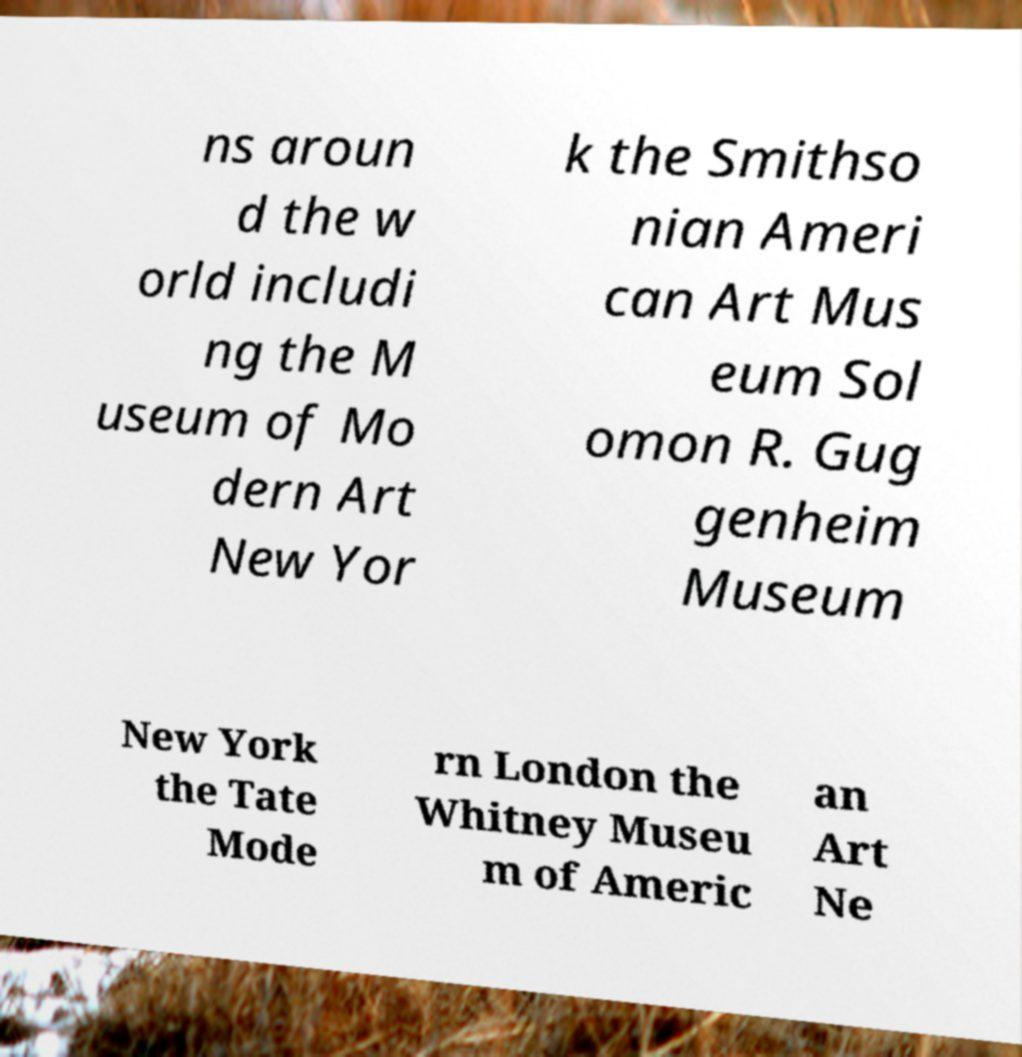Please read and relay the text visible in this image. What does it say? ns aroun d the w orld includi ng the M useum of Mo dern Art New Yor k the Smithso nian Ameri can Art Mus eum Sol omon R. Gug genheim Museum New York the Tate Mode rn London the Whitney Museu m of Americ an Art Ne 